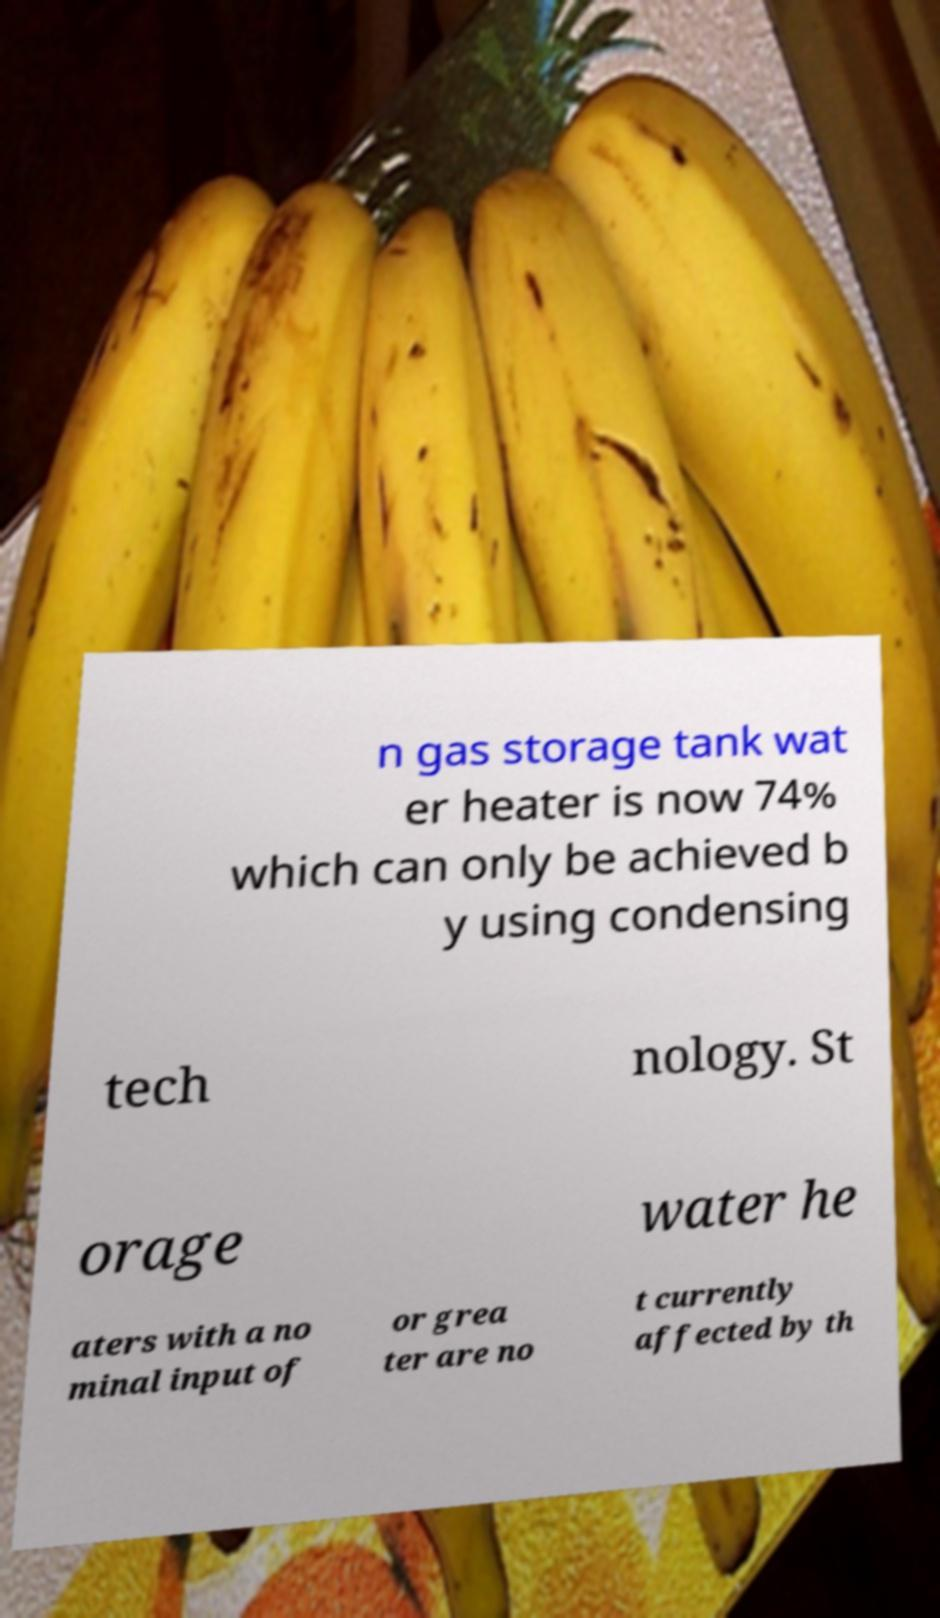Please identify and transcribe the text found in this image. n gas storage tank wat er heater is now 74% which can only be achieved b y using condensing tech nology. St orage water he aters with a no minal input of or grea ter are no t currently affected by th 